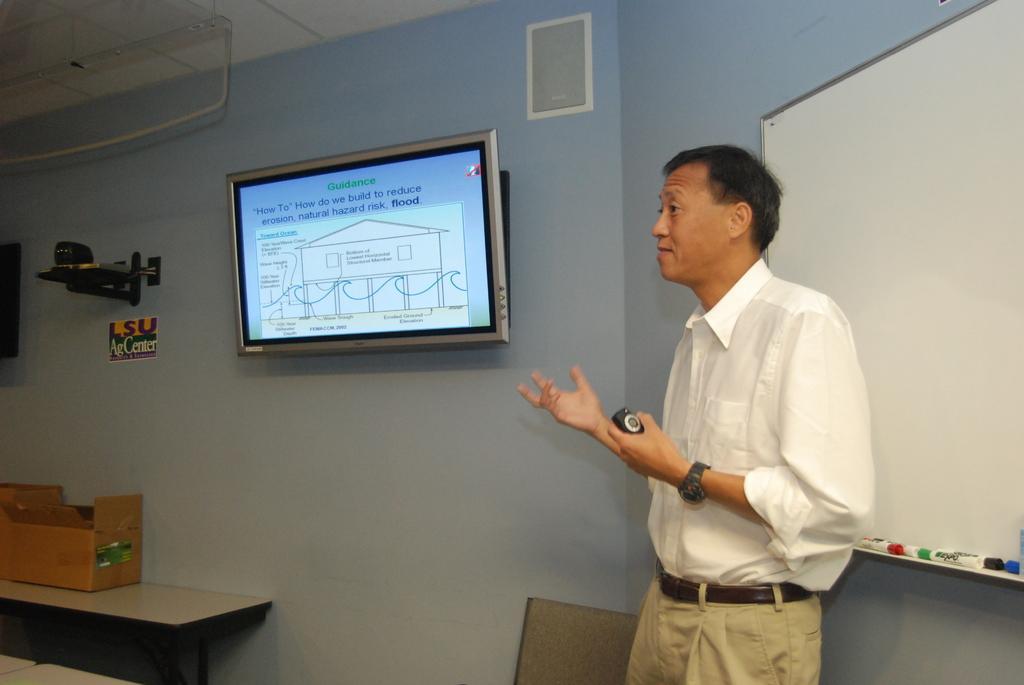Could you give a brief overview of what you see in this image? As we can see in the image there is a wall, screen, a man standing on the right side. He is wearing white color shirt and watch. On the right side there is a table. On table there is a box. 